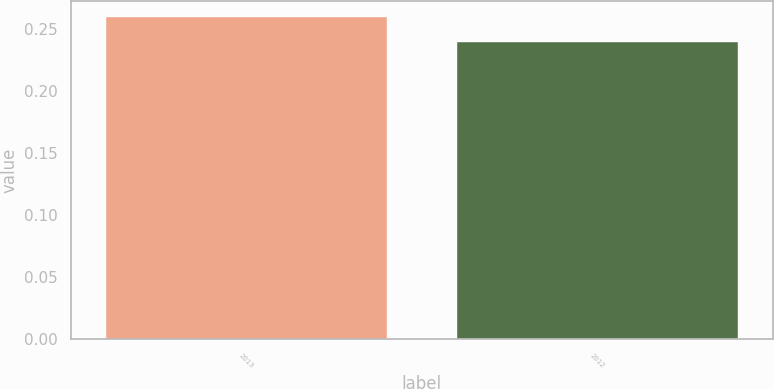<chart> <loc_0><loc_0><loc_500><loc_500><bar_chart><fcel>2013<fcel>2012<nl><fcel>0.26<fcel>0.24<nl></chart> 